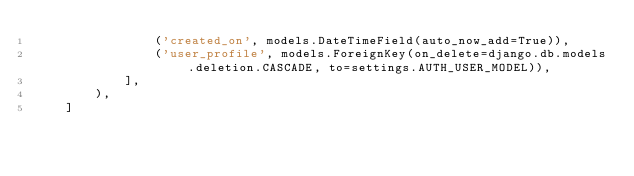Convert code to text. <code><loc_0><loc_0><loc_500><loc_500><_Python_>                ('created_on', models.DateTimeField(auto_now_add=True)),
                ('user_profile', models.ForeignKey(on_delete=django.db.models.deletion.CASCADE, to=settings.AUTH_USER_MODEL)),
            ],
        ),
    ]
</code> 